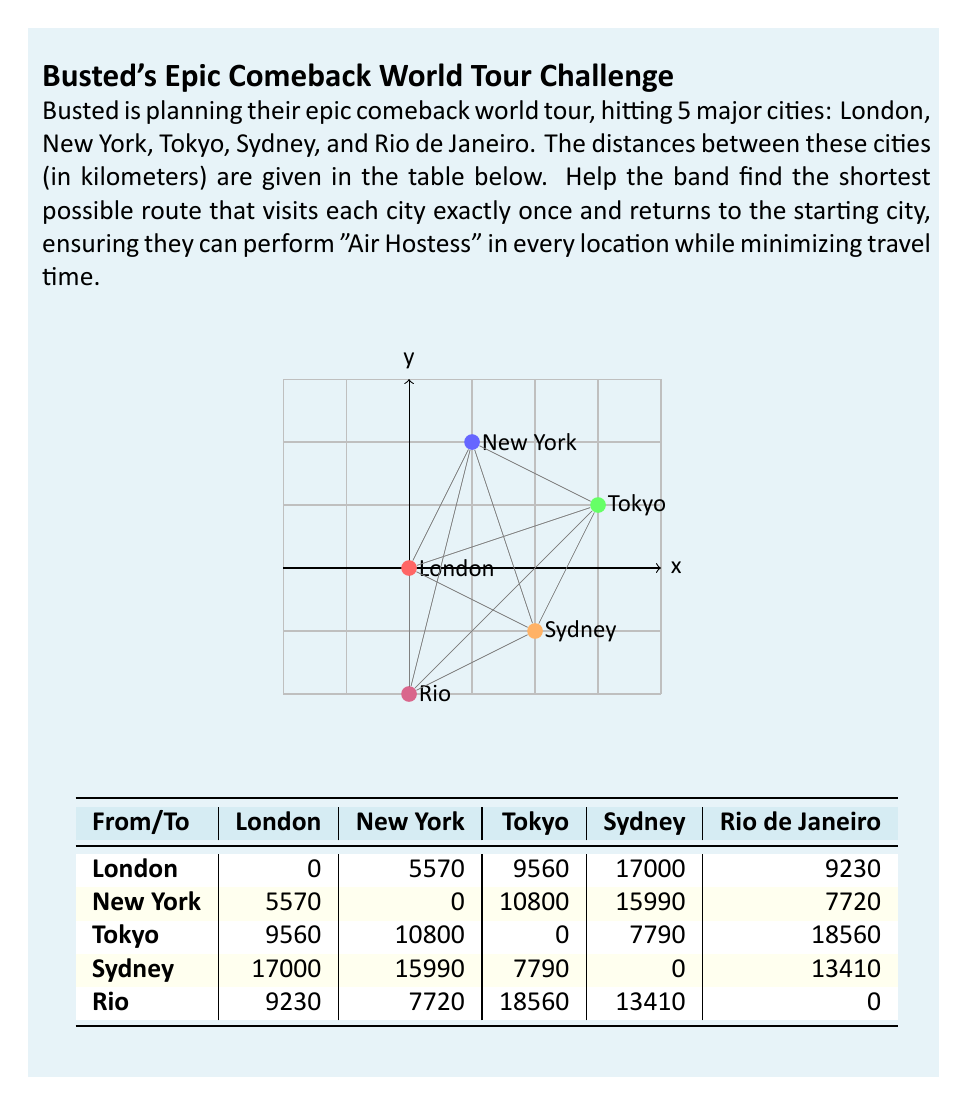Can you solve this math problem? To solve this problem, we need to use the Traveling Salesman Problem (TSP) algorithm. Since there are only 5 cities, we can use the brute force method to find the optimal solution.

Step 1: List all possible permutations of the cities (excluding London as the starting and ending point).
There are 4! = 24 possible permutations.

Step 2: Calculate the total distance for each permutation.
For example, let's calculate the distance for the route: London → New York → Tokyo → Sydney → Rio → London

Distance = 5570 + 10800 + 7790 + 13410 + 9230 = 46800 km

Step 3: Repeat step 2 for all permutations and find the one with the shortest total distance.

After calculating all permutations, we find that the shortest route is:

London → New York → Rio de Janeiro → Sydney → Tokyo → London

Step 4: Calculate the total distance for the optimal route:
$$\text{Total Distance} = 5570 + 7720 + 13410 + 7790 + 9560 = 44050 \text{ km}$$

This route allows Busted to perform "Air Hostess" in each city while minimizing their total travel distance, ensuring they have more time for songwriting and rehearsals between shows.
Answer: London → New York → Rio de Janeiro → Sydney → Tokyo → London; 44050 km 